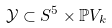Convert formula to latex. <formula><loc_0><loc_0><loc_500><loc_500>\mathcal { Y } \subset S ^ { 5 } \times \mathbb { P } V _ { k }</formula> 